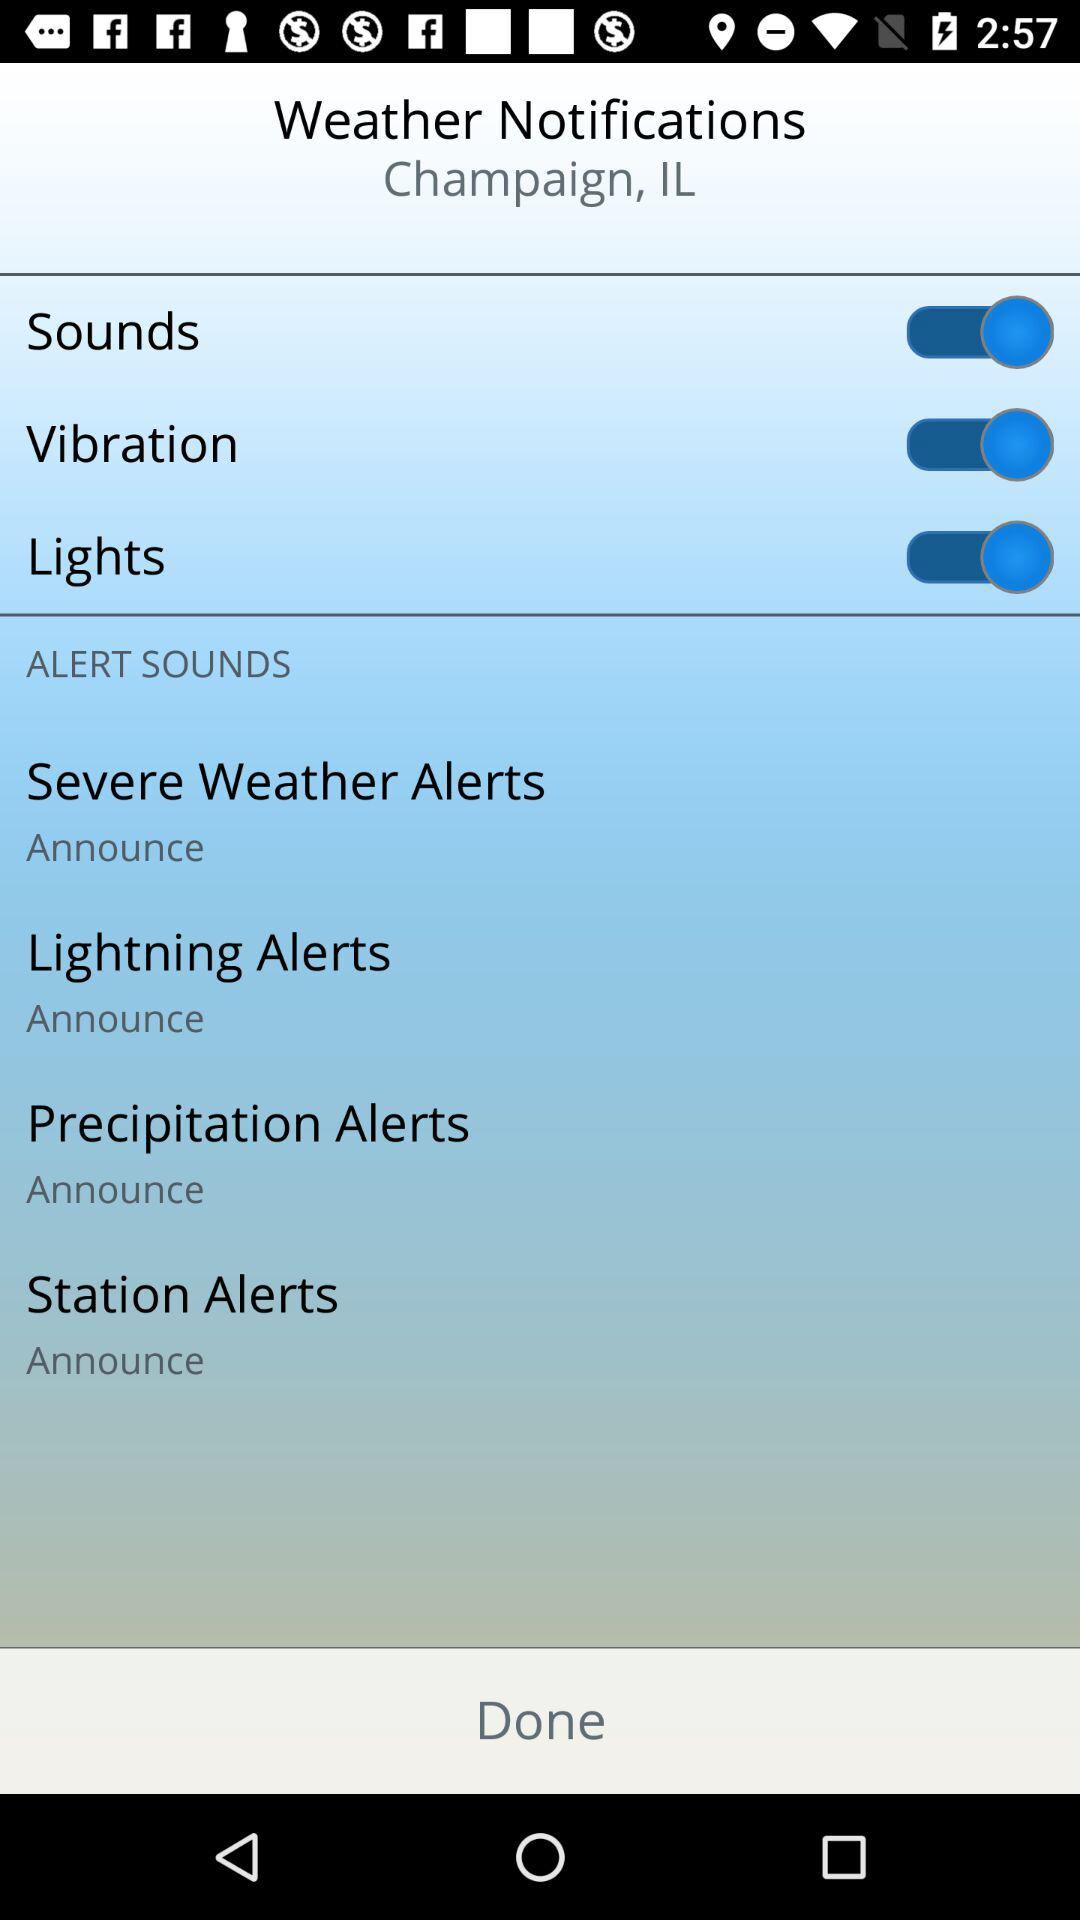How many alert sounds are there?
Answer the question using a single word or phrase. 4 